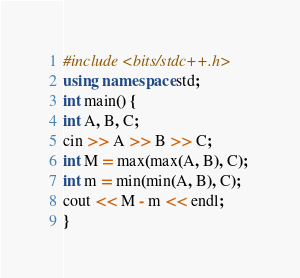Convert code to text. <code><loc_0><loc_0><loc_500><loc_500><_C++_>#include <bits/stdc++.h>
using namespace std;
int main() {
int A, B, C; 
cin >> A >> B >> C;
int M = max(max(A, B), C); 
int m = min(min(A, B), C); 
cout << M - m << endl; 
}</code> 